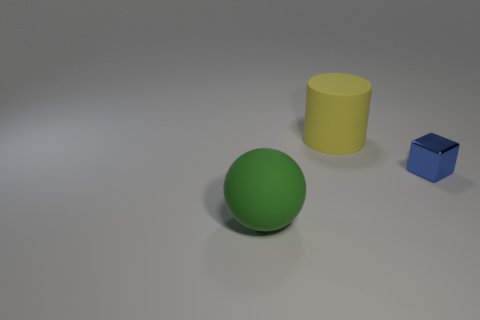What shape is the large matte object that is to the right of the large matte thing that is on the left side of the large yellow rubber object?
Your answer should be compact. Cylinder. There is a thing that is the same size as the yellow rubber cylinder; what is its shape?
Make the answer very short. Sphere. What is the blue cube made of?
Give a very brief answer. Metal. There is a block; are there any large things behind it?
Give a very brief answer. Yes. There is a rubber thing to the left of the yellow rubber cylinder; what number of large yellow things are in front of it?
Give a very brief answer. 0. How many other objects are the same material as the yellow object?
Give a very brief answer. 1. How many shiny objects are behind the yellow thing?
Provide a short and direct response. 0. How many balls are small metallic things or yellow things?
Provide a short and direct response. 0. There is a thing that is in front of the big yellow rubber thing and behind the big green rubber ball; what size is it?
Provide a succinct answer. Small. What number of other things are the same color as the tiny cube?
Keep it short and to the point. 0. 